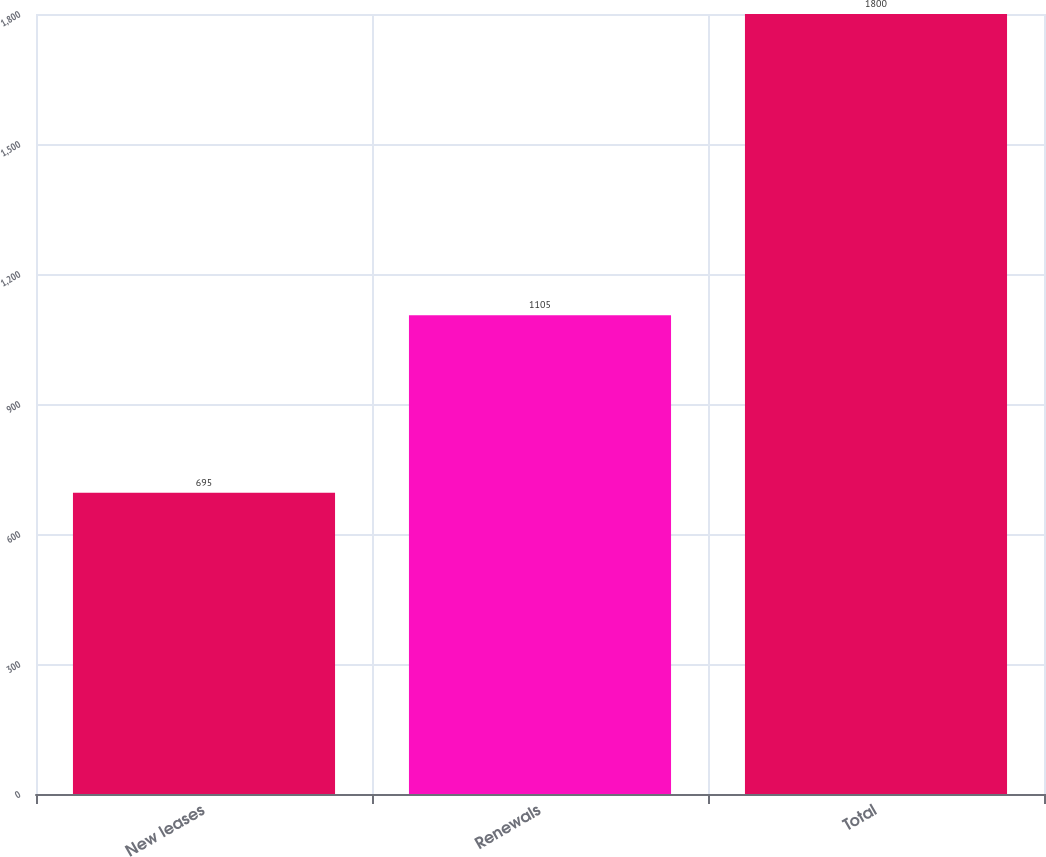Convert chart. <chart><loc_0><loc_0><loc_500><loc_500><bar_chart><fcel>New leases<fcel>Renewals<fcel>Total<nl><fcel>695<fcel>1105<fcel>1800<nl></chart> 